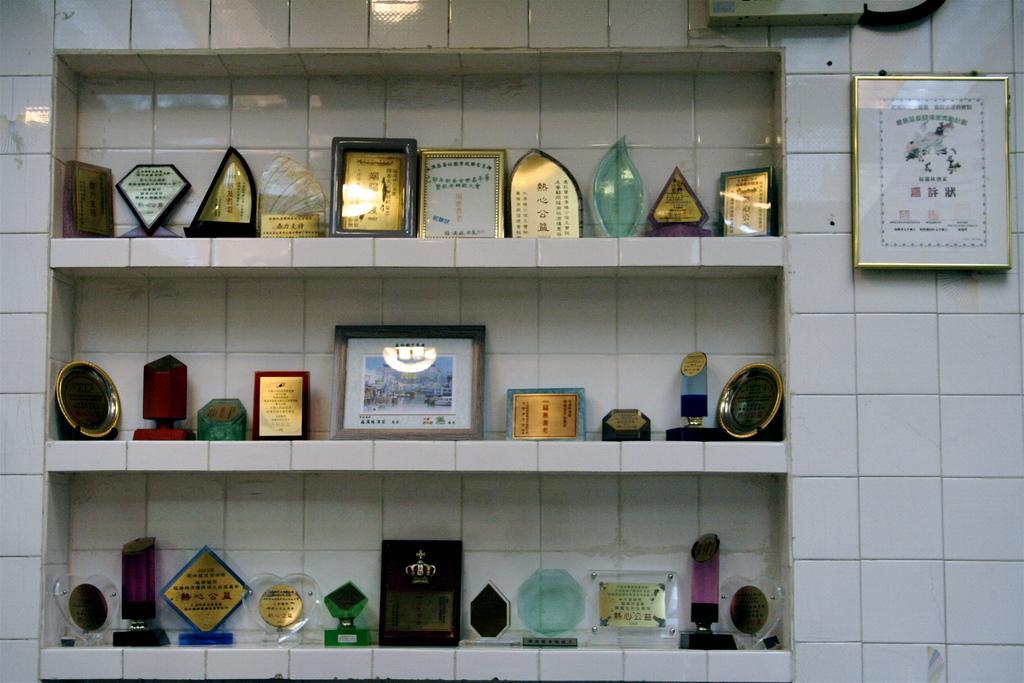Describe this image in one or two sentences. In the image we can see a wall, on the wall there are some frames and shields. 